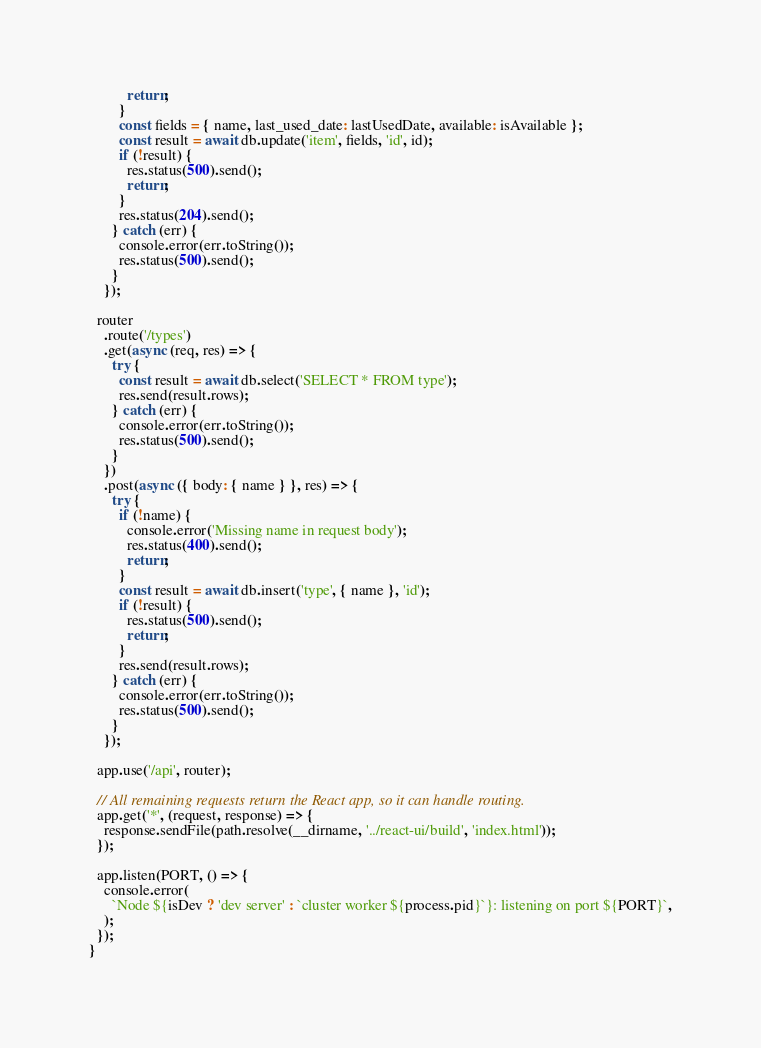<code> <loc_0><loc_0><loc_500><loc_500><_JavaScript_>          return;
        }
        const fields = { name, last_used_date: lastUsedDate, available: isAvailable };
        const result = await db.update('item', fields, 'id', id);
        if (!result) {
          res.status(500).send();
          return;
        }
        res.status(204).send();
      } catch (err) {
        console.error(err.toString());
        res.status(500).send();
      }
    });

  router
    .route('/types')
    .get(async (req, res) => {
      try {
        const result = await db.select('SELECT * FROM type');
        res.send(result.rows);
      } catch (err) {
        console.error(err.toString());
        res.status(500).send();
      }
    })
    .post(async ({ body: { name } }, res) => {
      try {
        if (!name) {
          console.error('Missing name in request body');
          res.status(400).send();
          return;
        }
        const result = await db.insert('type', { name }, 'id');
        if (!result) {
          res.status(500).send();
          return;
        }
        res.send(result.rows);
      } catch (err) {
        console.error(err.toString());
        res.status(500).send();
      }
    });

  app.use('/api', router);

  // All remaining requests return the React app, so it can handle routing.
  app.get('*', (request, response) => {
    response.sendFile(path.resolve(__dirname, '../react-ui/build', 'index.html'));
  });

  app.listen(PORT, () => {
    console.error(
      `Node ${isDev ? 'dev server' : `cluster worker ${process.pid}`}: listening on port ${PORT}`,
    );
  });
}
</code> 